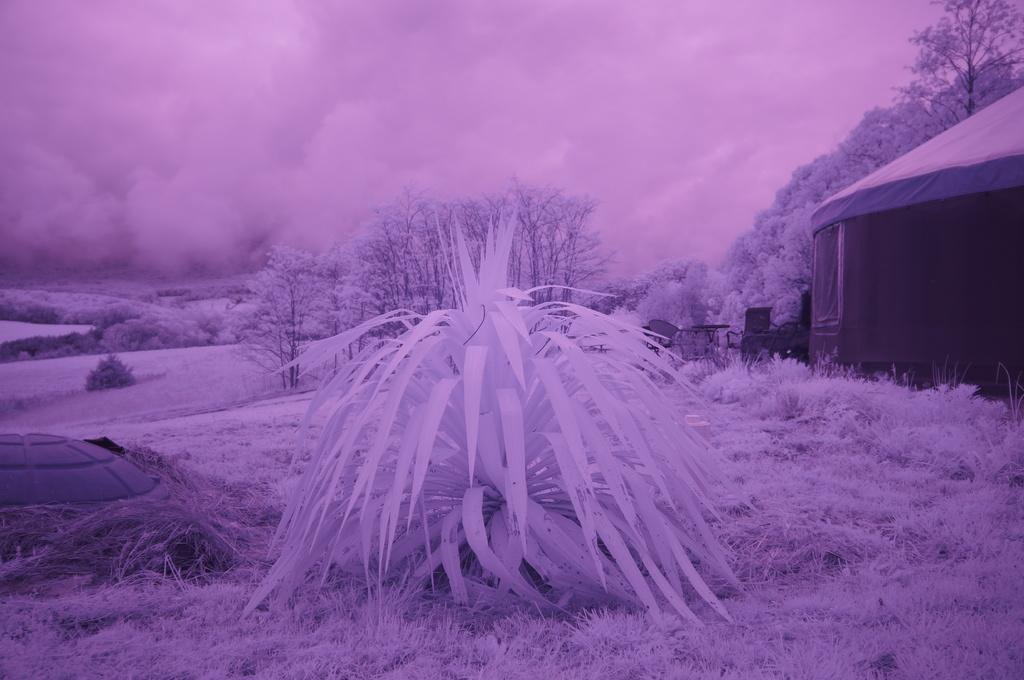Describe this image in one or two sentences. In the image there are trees, grass and on the right side it looks like there is a tent. The image is in the purple color. 